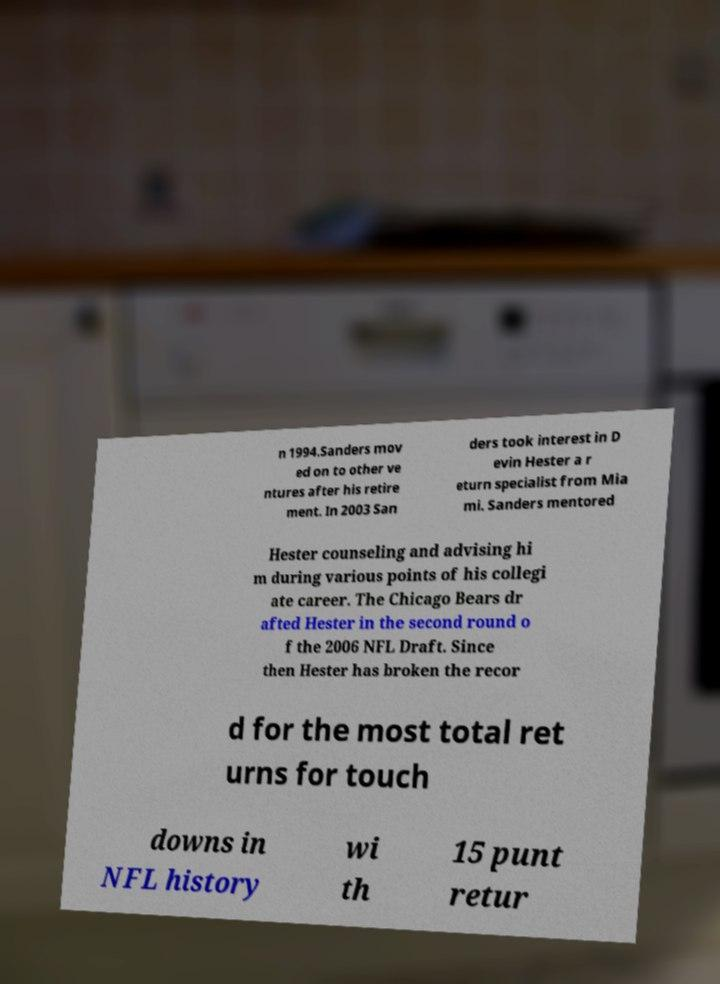Please identify and transcribe the text found in this image. n 1994.Sanders mov ed on to other ve ntures after his retire ment. In 2003 San ders took interest in D evin Hester a r eturn specialist from Mia mi. Sanders mentored Hester counseling and advising hi m during various points of his collegi ate career. The Chicago Bears dr afted Hester in the second round o f the 2006 NFL Draft. Since then Hester has broken the recor d for the most total ret urns for touch downs in NFL history wi th 15 punt retur 